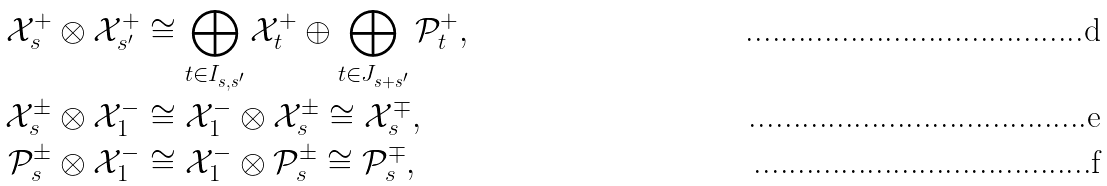<formula> <loc_0><loc_0><loc_500><loc_500>\mathcal { X } _ { s } ^ { + } \otimes \mathcal { X } _ { s ^ { \prime } } ^ { + } & \cong \bigoplus _ { t \in I _ { s , s ^ { \prime } } } \mathcal { X } _ { t } ^ { + } \oplus \bigoplus _ { t \in J _ { s + s ^ { \prime } } } \mathcal { P } _ { t } ^ { + } , \\ \mathcal { X } _ { s } ^ { \pm } \otimes \mathcal { X } _ { 1 } ^ { - } & \cong \mathcal { X } _ { 1 } ^ { - } \otimes \mathcal { X } _ { s } ^ { \pm } \cong \mathcal { X } _ { s } ^ { \mp } , \\ \mathcal { P } _ { s } ^ { \pm } \otimes \mathcal { X } _ { 1 } ^ { - } & \cong \mathcal { X } _ { 1 } ^ { - } \otimes \mathcal { P } _ { s } ^ { \pm } \cong \mathcal { P } _ { s } ^ { \mp } ,</formula> 